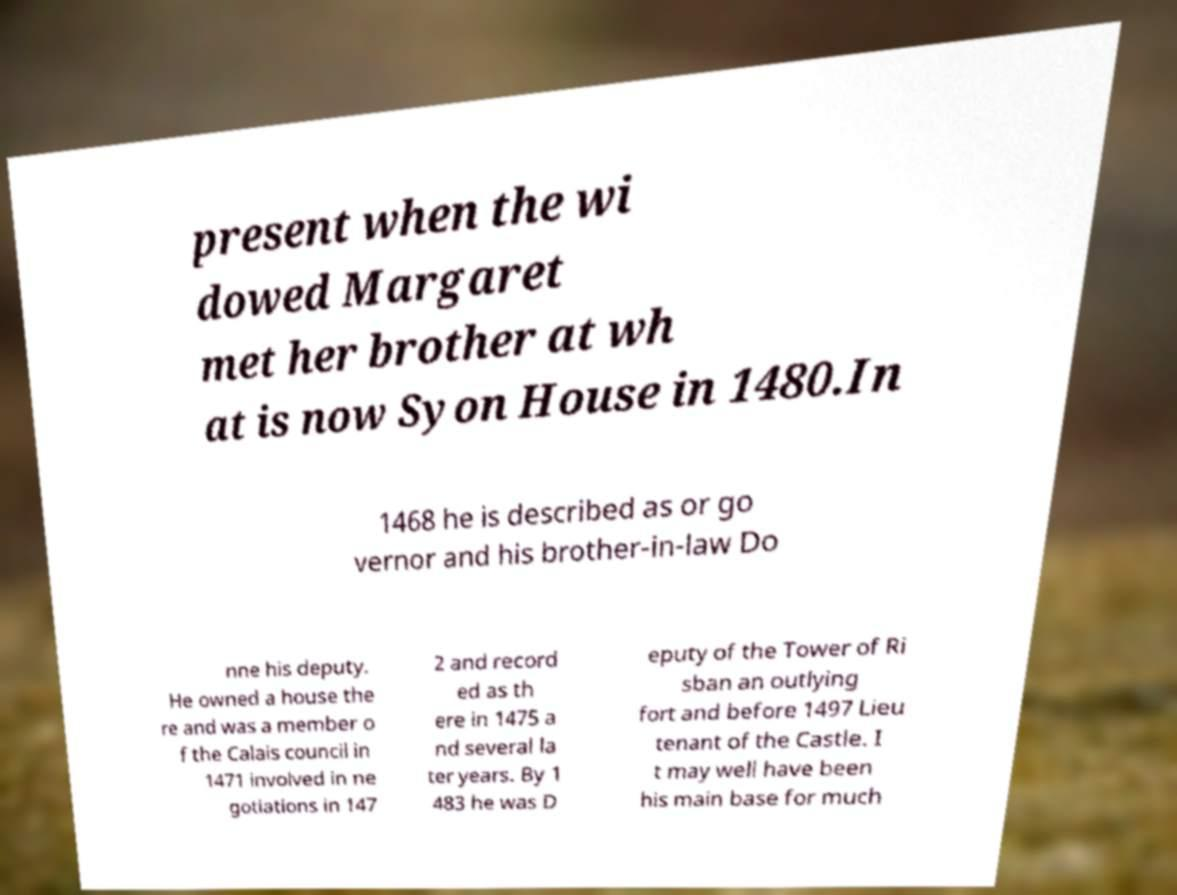What messages or text are displayed in this image? I need them in a readable, typed format. present when the wi dowed Margaret met her brother at wh at is now Syon House in 1480.In 1468 he is described as or go vernor and his brother-in-law Do nne his deputy. He owned a house the re and was a member o f the Calais council in 1471 involved in ne gotiations in 147 2 and record ed as th ere in 1475 a nd several la ter years. By 1 483 he was D eputy of the Tower of Ri sban an outlying fort and before 1497 Lieu tenant of the Castle. I t may well have been his main base for much 